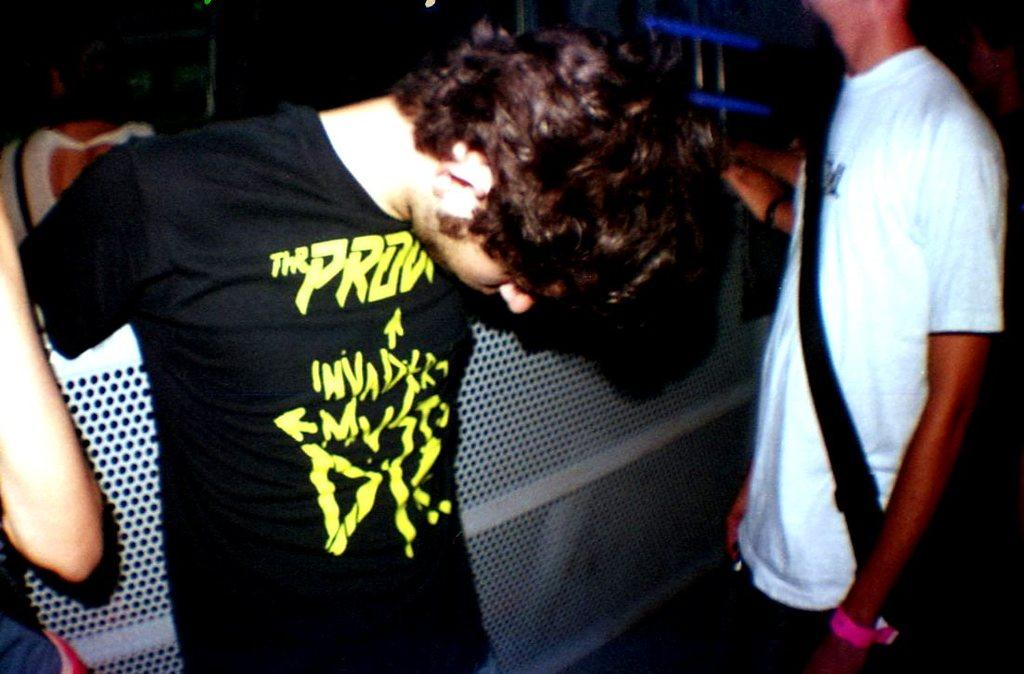Who or what can be seen in the image? There are people in the image. What else is present in the image besides the people? There is an object in the image. Can you describe the background of the image? The background of the image is dark. What type of lip can be seen on the object in the image? There is no lip present on the object in the image. How does the education level of the people in the image affect their temper? The education level of the people in the image cannot be determined from the image, and their temper is not mentioned or visible. 